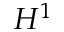Convert formula to latex. <formula><loc_0><loc_0><loc_500><loc_500>H ^ { 1 }</formula> 